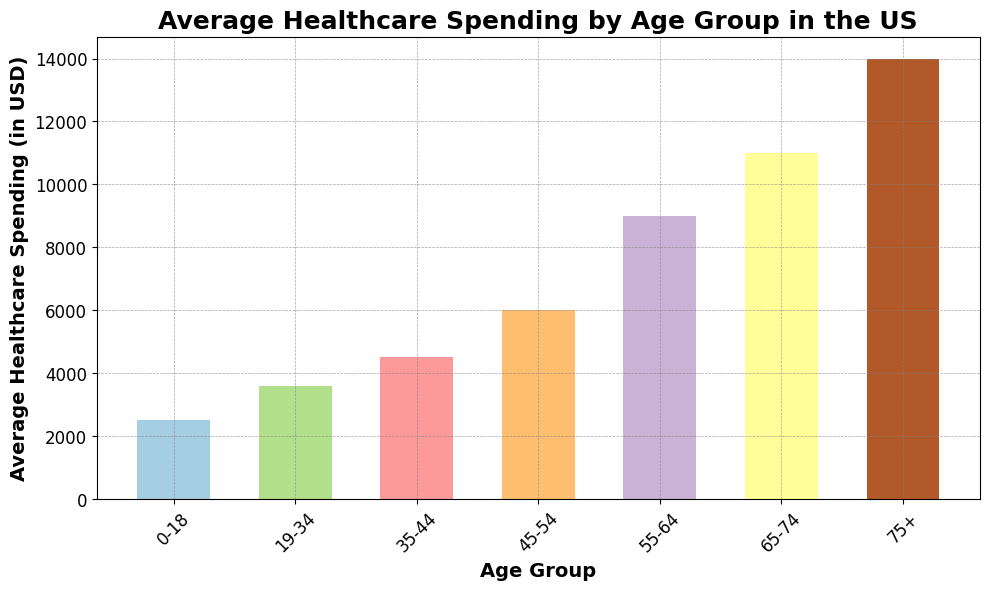What age group has the highest average healthcare spending? The figure shows that the age group 75+ has the highest bar, indicating it has the highest average healthcare spending.
Answer: 75+ Which age group has the lowest average healthcare spending? The bar for the age group 0-18 is the shortest, indicating it has the lowest average healthcare spending.
Answer: 0-18 What is the difference in average healthcare spending between the age groups 55-64 and 65-74? The average healthcare spending for 55-64 is 9000 USD and for 65-74 is 11000 USD. The difference is 11000 - 9000 = 2000 USD.
Answer: 2000 USD How much more does the age group 75+ spend on average compared to the age group 19-34? The average healthcare spending for 75+ is 14000 USD and for 19-34 is 3600 USD. The difference is 14000 - 3600 = 10400 USD.
Answer: 10400 USD Is the average healthcare spending for age group 45-54 higher or lower than that for age group 35-44? The bar for the age group 45-54 is taller than the one for 35-44, indicating higher average spending.
Answer: Higher What is the total average healthcare spending for all the age groups combined? Sum the average healthcare spending for each age group: 2500 + 3600 + 4500 + 6000 + 9000 + 11000 + 14000 = 50600 USD.
Answer: 50600 USD How does the average healthcare spending for the age group 0-18 compare to the age group 45-54? The bar for 0-18 is shorter than the bar for 45-54, indicating lower average spending for the younger age group.
Answer: Lower What is the average of the average healthcare spending for the three oldest age groups (55-64, 65-74, 75+)? Sum the average healthcare spending for 55-64, 65-74, and 75+: 9000 + 11000 + 14000 = 34000. Then divide by 3 to find the average: 34000 / 3 ≈ 11333.33 USD.
Answer: 11333.33 USD 